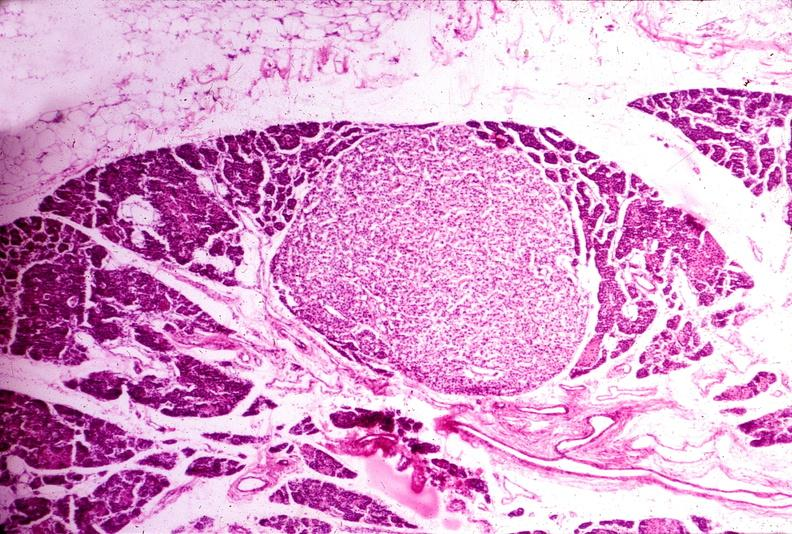s endocrine present?
Answer the question using a single word or phrase. Yes 